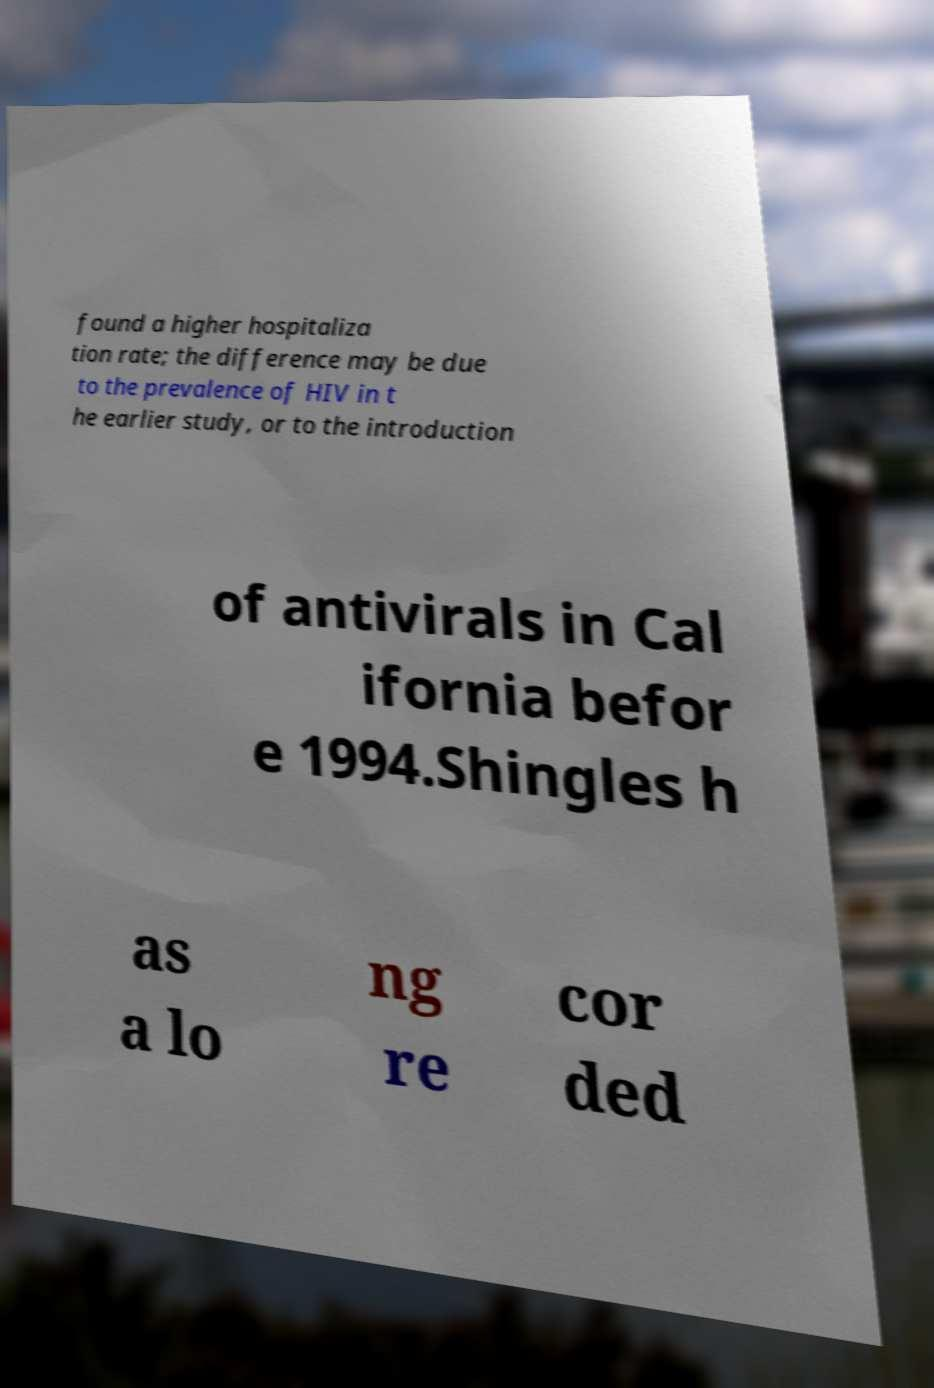There's text embedded in this image that I need extracted. Can you transcribe it verbatim? found a higher hospitaliza tion rate; the difference may be due to the prevalence of HIV in t he earlier study, or to the introduction of antivirals in Cal ifornia befor e 1994.Shingles h as a lo ng re cor ded 